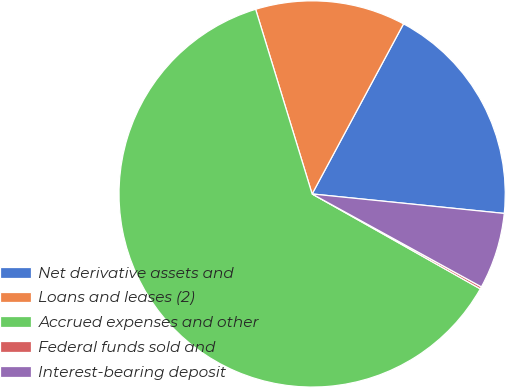Convert chart. <chart><loc_0><loc_0><loc_500><loc_500><pie_chart><fcel>Net derivative assets and<fcel>Loans and leases (2)<fcel>Accrued expenses and other<fcel>Federal funds sold and<fcel>Interest-bearing deposit<nl><fcel>18.76%<fcel>12.57%<fcel>62.09%<fcel>0.19%<fcel>6.38%<nl></chart> 